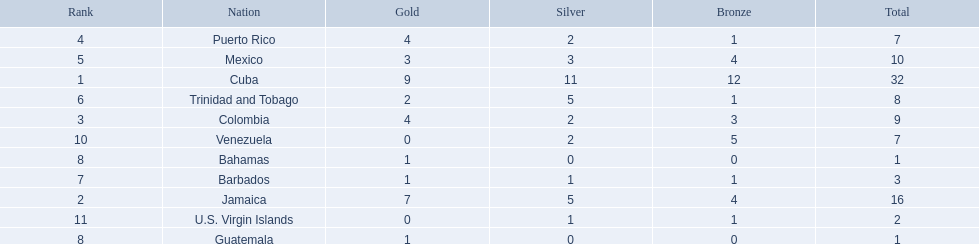The nation before mexico in the table Puerto Rico. 